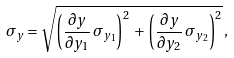<formula> <loc_0><loc_0><loc_500><loc_500>\sigma _ { y } = \sqrt { \left ( \frac { \partial y } { \partial y _ { 1 } } \, \sigma _ { y _ { 1 } } \right ) ^ { 2 } \, + \, \left ( \frac { \partial y } { \partial y _ { 2 } } \, \sigma _ { y _ { 2 } } \right ) ^ { 2 } } \, ,</formula> 